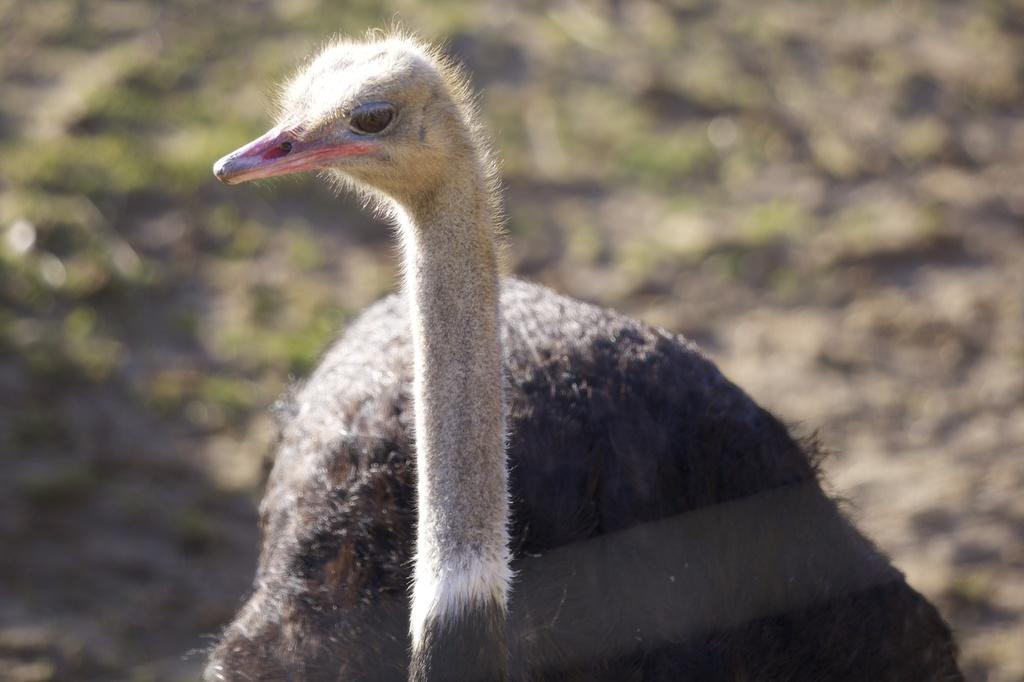What animal is the main subject of the image? There is an ostrich in the image. What type of vegetation is present in the image? There is grass in the image. Can you describe the background of the image? The background of the image is blurred. How does the tree contribute to the harmony of the image? There is no tree present in the image, so it cannot contribute to the harmony. 